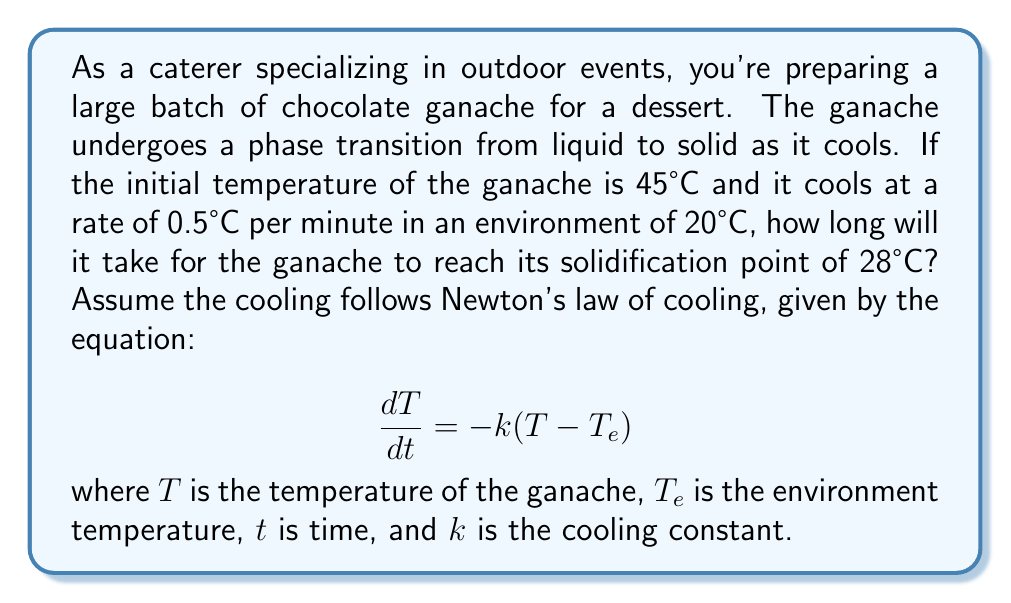What is the answer to this math problem? To solve this problem, we need to follow these steps:

1) First, we need to determine the cooling constant $k$. We're given that the cooling rate is 0.5°C per minute when the ganache is at 45°C. We can use this information in Newton's law of cooling:

   $$0.5 = k(45 - 20)$$
   $$0.5 = 25k$$
   $$k = 0.02 \text{ min}^{-1}$$

2) Now that we have $k$, we can use the integrated form of Newton's law of cooling:

   $$T(t) = T_e + (T_0 - T_e)e^{-kt}$$

   where $T(t)$ is the temperature at time $t$, $T_0$ is the initial temperature, and $T_e$ is the environment temperature.

3) We want to find $t$ when $T(t) = 28°C$. Let's substitute all known values:

   $$28 = 20 + (45 - 20)e^{-0.02t}$$

4) Solve for $t$:
   
   $$8 = 25e^{-0.02t}$$
   $$\frac{8}{25} = e^{-0.02t}$$
   $$\ln(\frac{8}{25}) = -0.02t$$
   $$t = -\frac{\ln(\frac{8}{25})}{0.02} \approx 57.57 \text{ minutes}$$

Therefore, it will take approximately 57.57 minutes for the ganache to reach its solidification point.
Answer: 57.57 minutes 